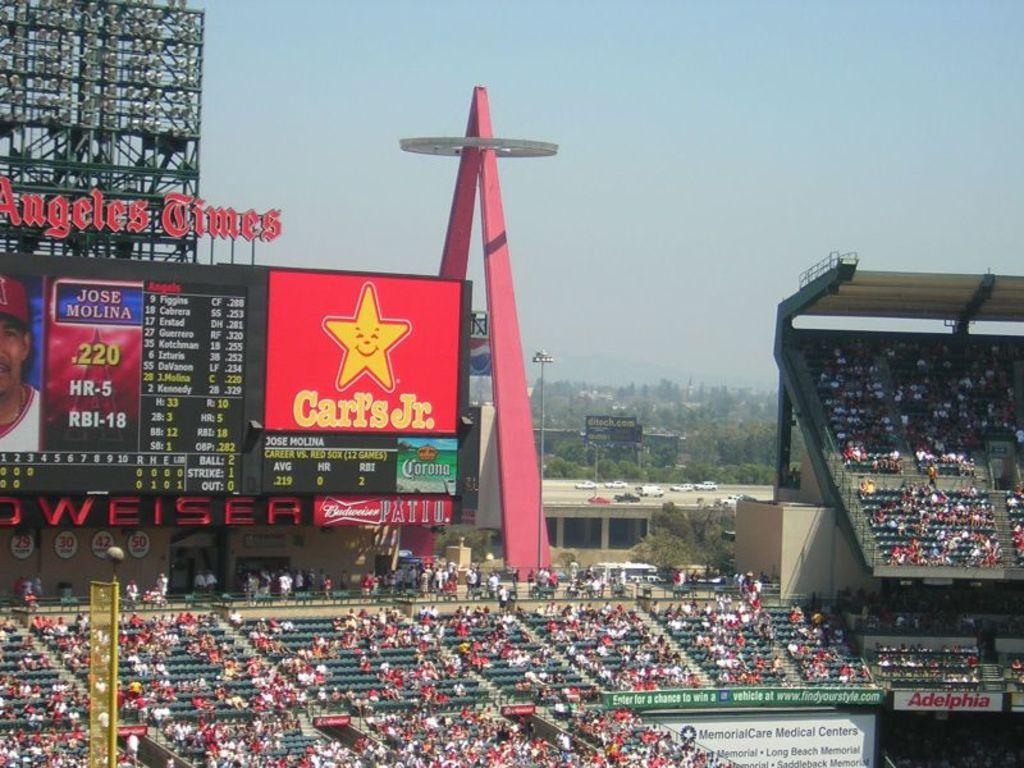<image>
Create a compact narrative representing the image presented. The score board at this baseball stadium shows an advertisement by Carl's Jr. 